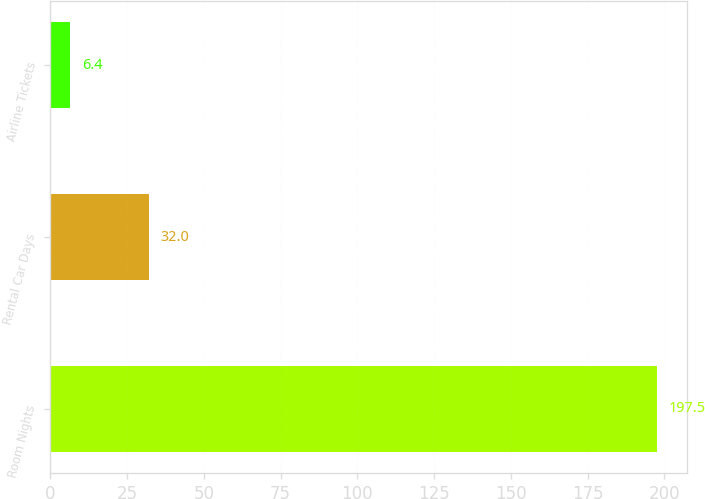<chart> <loc_0><loc_0><loc_500><loc_500><bar_chart><fcel>Room Nights<fcel>Rental Car Days<fcel>Airline Tickets<nl><fcel>197.5<fcel>32<fcel>6.4<nl></chart> 